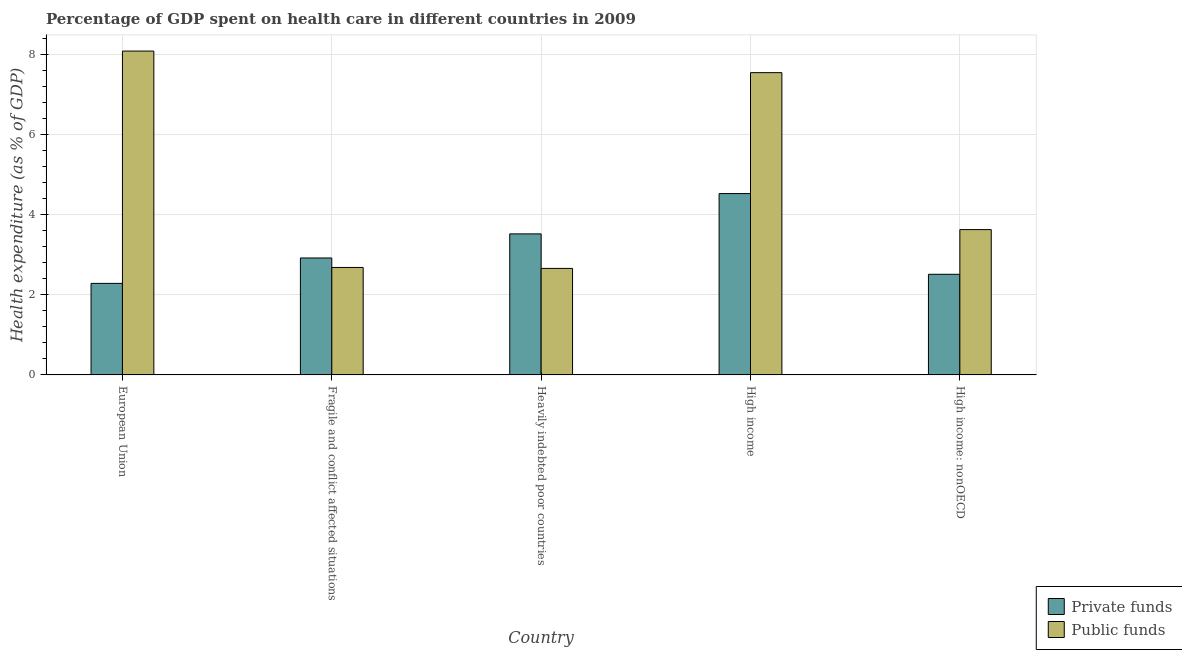Are the number of bars on each tick of the X-axis equal?
Offer a terse response. Yes. How many bars are there on the 3rd tick from the right?
Provide a succinct answer. 2. What is the amount of public funds spent in healthcare in High income?
Ensure brevity in your answer.  7.55. Across all countries, what is the maximum amount of public funds spent in healthcare?
Provide a succinct answer. 8.09. Across all countries, what is the minimum amount of public funds spent in healthcare?
Provide a short and direct response. 2.66. What is the total amount of public funds spent in healthcare in the graph?
Offer a very short reply. 24.62. What is the difference between the amount of private funds spent in healthcare in European Union and that in Heavily indebted poor countries?
Offer a terse response. -1.24. What is the difference between the amount of public funds spent in healthcare in European Union and the amount of private funds spent in healthcare in Fragile and conflict affected situations?
Provide a short and direct response. 5.17. What is the average amount of public funds spent in healthcare per country?
Offer a very short reply. 4.92. What is the difference between the amount of private funds spent in healthcare and amount of public funds spent in healthcare in Fragile and conflict affected situations?
Offer a terse response. 0.24. What is the ratio of the amount of public funds spent in healthcare in Fragile and conflict affected situations to that in Heavily indebted poor countries?
Give a very brief answer. 1.01. Is the amount of public funds spent in healthcare in Heavily indebted poor countries less than that in High income?
Give a very brief answer. Yes. What is the difference between the highest and the second highest amount of private funds spent in healthcare?
Keep it short and to the point. 1.01. What is the difference between the highest and the lowest amount of public funds spent in healthcare?
Your answer should be very brief. 5.43. In how many countries, is the amount of private funds spent in healthcare greater than the average amount of private funds spent in healthcare taken over all countries?
Keep it short and to the point. 2. What does the 1st bar from the left in European Union represents?
Give a very brief answer. Private funds. What does the 1st bar from the right in European Union represents?
Your response must be concise. Public funds. How many bars are there?
Offer a terse response. 10. Are all the bars in the graph horizontal?
Offer a terse response. No. How many countries are there in the graph?
Give a very brief answer. 5. Does the graph contain grids?
Your answer should be compact. Yes. What is the title of the graph?
Your answer should be very brief. Percentage of GDP spent on health care in different countries in 2009. Does "Investment in Telecom" appear as one of the legend labels in the graph?
Offer a very short reply. No. What is the label or title of the X-axis?
Ensure brevity in your answer.  Country. What is the label or title of the Y-axis?
Your answer should be very brief. Health expenditure (as % of GDP). What is the Health expenditure (as % of GDP) in Private funds in European Union?
Make the answer very short. 2.29. What is the Health expenditure (as % of GDP) of Public funds in European Union?
Ensure brevity in your answer.  8.09. What is the Health expenditure (as % of GDP) in Private funds in Fragile and conflict affected situations?
Provide a succinct answer. 2.92. What is the Health expenditure (as % of GDP) in Public funds in Fragile and conflict affected situations?
Provide a short and direct response. 2.68. What is the Health expenditure (as % of GDP) in Private funds in Heavily indebted poor countries?
Offer a terse response. 3.52. What is the Health expenditure (as % of GDP) of Public funds in Heavily indebted poor countries?
Your answer should be very brief. 2.66. What is the Health expenditure (as % of GDP) in Private funds in High income?
Keep it short and to the point. 4.53. What is the Health expenditure (as % of GDP) in Public funds in High income?
Ensure brevity in your answer.  7.55. What is the Health expenditure (as % of GDP) in Private funds in High income: nonOECD?
Provide a short and direct response. 2.51. What is the Health expenditure (as % of GDP) of Public funds in High income: nonOECD?
Provide a succinct answer. 3.63. Across all countries, what is the maximum Health expenditure (as % of GDP) of Private funds?
Your answer should be very brief. 4.53. Across all countries, what is the maximum Health expenditure (as % of GDP) in Public funds?
Provide a succinct answer. 8.09. Across all countries, what is the minimum Health expenditure (as % of GDP) of Private funds?
Make the answer very short. 2.29. Across all countries, what is the minimum Health expenditure (as % of GDP) of Public funds?
Ensure brevity in your answer.  2.66. What is the total Health expenditure (as % of GDP) in Private funds in the graph?
Your answer should be very brief. 15.78. What is the total Health expenditure (as % of GDP) in Public funds in the graph?
Your answer should be compact. 24.62. What is the difference between the Health expenditure (as % of GDP) of Private funds in European Union and that in Fragile and conflict affected situations?
Provide a short and direct response. -0.63. What is the difference between the Health expenditure (as % of GDP) in Public funds in European Union and that in Fragile and conflict affected situations?
Offer a very short reply. 5.41. What is the difference between the Health expenditure (as % of GDP) in Private funds in European Union and that in Heavily indebted poor countries?
Give a very brief answer. -1.24. What is the difference between the Health expenditure (as % of GDP) of Public funds in European Union and that in Heavily indebted poor countries?
Keep it short and to the point. 5.43. What is the difference between the Health expenditure (as % of GDP) in Private funds in European Union and that in High income?
Offer a very short reply. -2.24. What is the difference between the Health expenditure (as % of GDP) in Public funds in European Union and that in High income?
Your answer should be very brief. 0.54. What is the difference between the Health expenditure (as % of GDP) in Private funds in European Union and that in High income: nonOECD?
Offer a terse response. -0.23. What is the difference between the Health expenditure (as % of GDP) in Public funds in European Union and that in High income: nonOECD?
Your answer should be very brief. 4.46. What is the difference between the Health expenditure (as % of GDP) in Private funds in Fragile and conflict affected situations and that in Heavily indebted poor countries?
Provide a short and direct response. -0.6. What is the difference between the Health expenditure (as % of GDP) of Public funds in Fragile and conflict affected situations and that in Heavily indebted poor countries?
Give a very brief answer. 0.02. What is the difference between the Health expenditure (as % of GDP) of Private funds in Fragile and conflict affected situations and that in High income?
Give a very brief answer. -1.61. What is the difference between the Health expenditure (as % of GDP) of Public funds in Fragile and conflict affected situations and that in High income?
Your answer should be very brief. -4.87. What is the difference between the Health expenditure (as % of GDP) in Private funds in Fragile and conflict affected situations and that in High income: nonOECD?
Your answer should be compact. 0.41. What is the difference between the Health expenditure (as % of GDP) in Public funds in Fragile and conflict affected situations and that in High income: nonOECD?
Provide a succinct answer. -0.95. What is the difference between the Health expenditure (as % of GDP) in Private funds in Heavily indebted poor countries and that in High income?
Your response must be concise. -1.01. What is the difference between the Health expenditure (as % of GDP) in Public funds in Heavily indebted poor countries and that in High income?
Provide a short and direct response. -4.89. What is the difference between the Health expenditure (as % of GDP) of Private funds in Heavily indebted poor countries and that in High income: nonOECD?
Your answer should be compact. 1.01. What is the difference between the Health expenditure (as % of GDP) of Public funds in Heavily indebted poor countries and that in High income: nonOECD?
Ensure brevity in your answer.  -0.97. What is the difference between the Health expenditure (as % of GDP) in Private funds in High income and that in High income: nonOECD?
Offer a terse response. 2.02. What is the difference between the Health expenditure (as % of GDP) of Public funds in High income and that in High income: nonOECD?
Give a very brief answer. 3.92. What is the difference between the Health expenditure (as % of GDP) in Private funds in European Union and the Health expenditure (as % of GDP) in Public funds in Fragile and conflict affected situations?
Your answer should be compact. -0.4. What is the difference between the Health expenditure (as % of GDP) in Private funds in European Union and the Health expenditure (as % of GDP) in Public funds in Heavily indebted poor countries?
Provide a succinct answer. -0.37. What is the difference between the Health expenditure (as % of GDP) of Private funds in European Union and the Health expenditure (as % of GDP) of Public funds in High income?
Your answer should be compact. -5.27. What is the difference between the Health expenditure (as % of GDP) of Private funds in European Union and the Health expenditure (as % of GDP) of Public funds in High income: nonOECD?
Provide a short and direct response. -1.34. What is the difference between the Health expenditure (as % of GDP) of Private funds in Fragile and conflict affected situations and the Health expenditure (as % of GDP) of Public funds in Heavily indebted poor countries?
Your answer should be very brief. 0.26. What is the difference between the Health expenditure (as % of GDP) of Private funds in Fragile and conflict affected situations and the Health expenditure (as % of GDP) of Public funds in High income?
Offer a terse response. -4.63. What is the difference between the Health expenditure (as % of GDP) in Private funds in Fragile and conflict affected situations and the Health expenditure (as % of GDP) in Public funds in High income: nonOECD?
Keep it short and to the point. -0.71. What is the difference between the Health expenditure (as % of GDP) of Private funds in Heavily indebted poor countries and the Health expenditure (as % of GDP) of Public funds in High income?
Keep it short and to the point. -4.03. What is the difference between the Health expenditure (as % of GDP) of Private funds in Heavily indebted poor countries and the Health expenditure (as % of GDP) of Public funds in High income: nonOECD?
Give a very brief answer. -0.11. What is the difference between the Health expenditure (as % of GDP) of Private funds in High income and the Health expenditure (as % of GDP) of Public funds in High income: nonOECD?
Give a very brief answer. 0.9. What is the average Health expenditure (as % of GDP) in Private funds per country?
Provide a short and direct response. 3.16. What is the average Health expenditure (as % of GDP) of Public funds per country?
Keep it short and to the point. 4.92. What is the difference between the Health expenditure (as % of GDP) in Private funds and Health expenditure (as % of GDP) in Public funds in European Union?
Offer a very short reply. -5.8. What is the difference between the Health expenditure (as % of GDP) of Private funds and Health expenditure (as % of GDP) of Public funds in Fragile and conflict affected situations?
Your answer should be compact. 0.24. What is the difference between the Health expenditure (as % of GDP) in Private funds and Health expenditure (as % of GDP) in Public funds in Heavily indebted poor countries?
Offer a terse response. 0.86. What is the difference between the Health expenditure (as % of GDP) of Private funds and Health expenditure (as % of GDP) of Public funds in High income?
Provide a succinct answer. -3.02. What is the difference between the Health expenditure (as % of GDP) of Private funds and Health expenditure (as % of GDP) of Public funds in High income: nonOECD?
Offer a very short reply. -1.12. What is the ratio of the Health expenditure (as % of GDP) of Private funds in European Union to that in Fragile and conflict affected situations?
Keep it short and to the point. 0.78. What is the ratio of the Health expenditure (as % of GDP) of Public funds in European Union to that in Fragile and conflict affected situations?
Provide a succinct answer. 3.01. What is the ratio of the Health expenditure (as % of GDP) in Private funds in European Union to that in Heavily indebted poor countries?
Make the answer very short. 0.65. What is the ratio of the Health expenditure (as % of GDP) in Public funds in European Union to that in Heavily indebted poor countries?
Your response must be concise. 3.04. What is the ratio of the Health expenditure (as % of GDP) in Private funds in European Union to that in High income?
Your response must be concise. 0.5. What is the ratio of the Health expenditure (as % of GDP) in Public funds in European Union to that in High income?
Keep it short and to the point. 1.07. What is the ratio of the Health expenditure (as % of GDP) of Private funds in European Union to that in High income: nonOECD?
Your answer should be compact. 0.91. What is the ratio of the Health expenditure (as % of GDP) in Public funds in European Union to that in High income: nonOECD?
Provide a succinct answer. 2.23. What is the ratio of the Health expenditure (as % of GDP) in Private funds in Fragile and conflict affected situations to that in Heavily indebted poor countries?
Offer a terse response. 0.83. What is the ratio of the Health expenditure (as % of GDP) of Public funds in Fragile and conflict affected situations to that in Heavily indebted poor countries?
Ensure brevity in your answer.  1.01. What is the ratio of the Health expenditure (as % of GDP) in Private funds in Fragile and conflict affected situations to that in High income?
Your response must be concise. 0.64. What is the ratio of the Health expenditure (as % of GDP) in Public funds in Fragile and conflict affected situations to that in High income?
Your answer should be compact. 0.36. What is the ratio of the Health expenditure (as % of GDP) of Private funds in Fragile and conflict affected situations to that in High income: nonOECD?
Provide a succinct answer. 1.16. What is the ratio of the Health expenditure (as % of GDP) in Public funds in Fragile and conflict affected situations to that in High income: nonOECD?
Keep it short and to the point. 0.74. What is the ratio of the Health expenditure (as % of GDP) in Private funds in Heavily indebted poor countries to that in High income?
Your answer should be compact. 0.78. What is the ratio of the Health expenditure (as % of GDP) in Public funds in Heavily indebted poor countries to that in High income?
Your response must be concise. 0.35. What is the ratio of the Health expenditure (as % of GDP) of Private funds in Heavily indebted poor countries to that in High income: nonOECD?
Make the answer very short. 1.4. What is the ratio of the Health expenditure (as % of GDP) in Public funds in Heavily indebted poor countries to that in High income: nonOECD?
Your answer should be very brief. 0.73. What is the ratio of the Health expenditure (as % of GDP) of Private funds in High income to that in High income: nonOECD?
Provide a short and direct response. 1.8. What is the ratio of the Health expenditure (as % of GDP) of Public funds in High income to that in High income: nonOECD?
Provide a succinct answer. 2.08. What is the difference between the highest and the second highest Health expenditure (as % of GDP) in Private funds?
Your answer should be compact. 1.01. What is the difference between the highest and the second highest Health expenditure (as % of GDP) of Public funds?
Offer a terse response. 0.54. What is the difference between the highest and the lowest Health expenditure (as % of GDP) of Private funds?
Offer a terse response. 2.24. What is the difference between the highest and the lowest Health expenditure (as % of GDP) of Public funds?
Give a very brief answer. 5.43. 